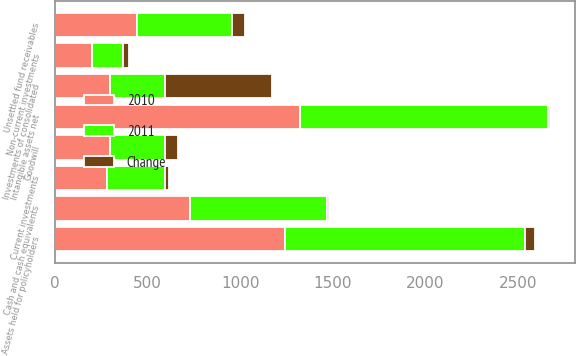<chart> <loc_0><loc_0><loc_500><loc_500><stacked_bar_chart><ecel><fcel>Cash and cash equivalents<fcel>Unsettled fund receivables<fcel>Current investments<fcel>Assets held for policyholders<fcel>Non-current investments<fcel>Investments of consolidated<fcel>Intangible assets net<fcel>Goodwill<nl><fcel>2010<fcel>727.4<fcel>444.4<fcel>283.7<fcel>1243.5<fcel>200.8<fcel>296.25<fcel>1322.8<fcel>296.25<nl><fcel>2011<fcel>740.5<fcel>513.4<fcel>308.8<fcel>1295.4<fcel>164.4<fcel>296.25<fcel>1337.2<fcel>296.25<nl><fcel>Change<fcel>13.1<fcel>69<fcel>25.1<fcel>51.9<fcel>36.4<fcel>577<fcel>14.4<fcel>72.3<nl></chart> 